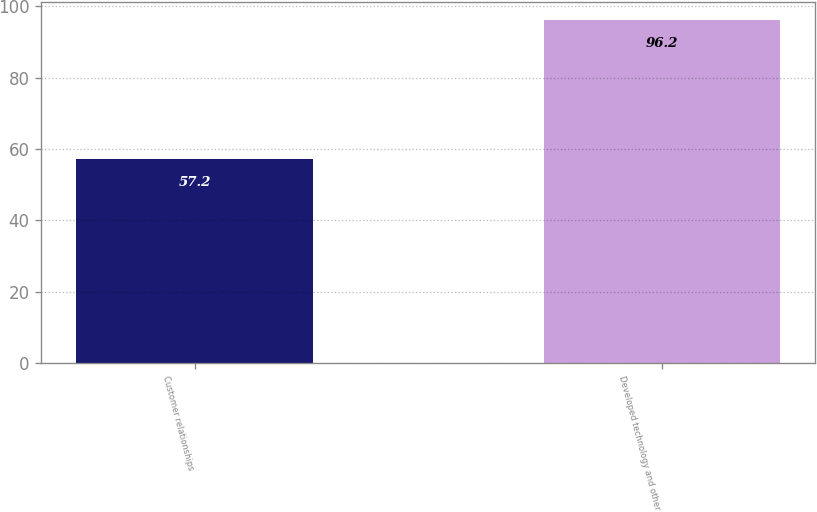<chart> <loc_0><loc_0><loc_500><loc_500><bar_chart><fcel>Customer relationships<fcel>Developed technology and other<nl><fcel>57.2<fcel>96.2<nl></chart> 